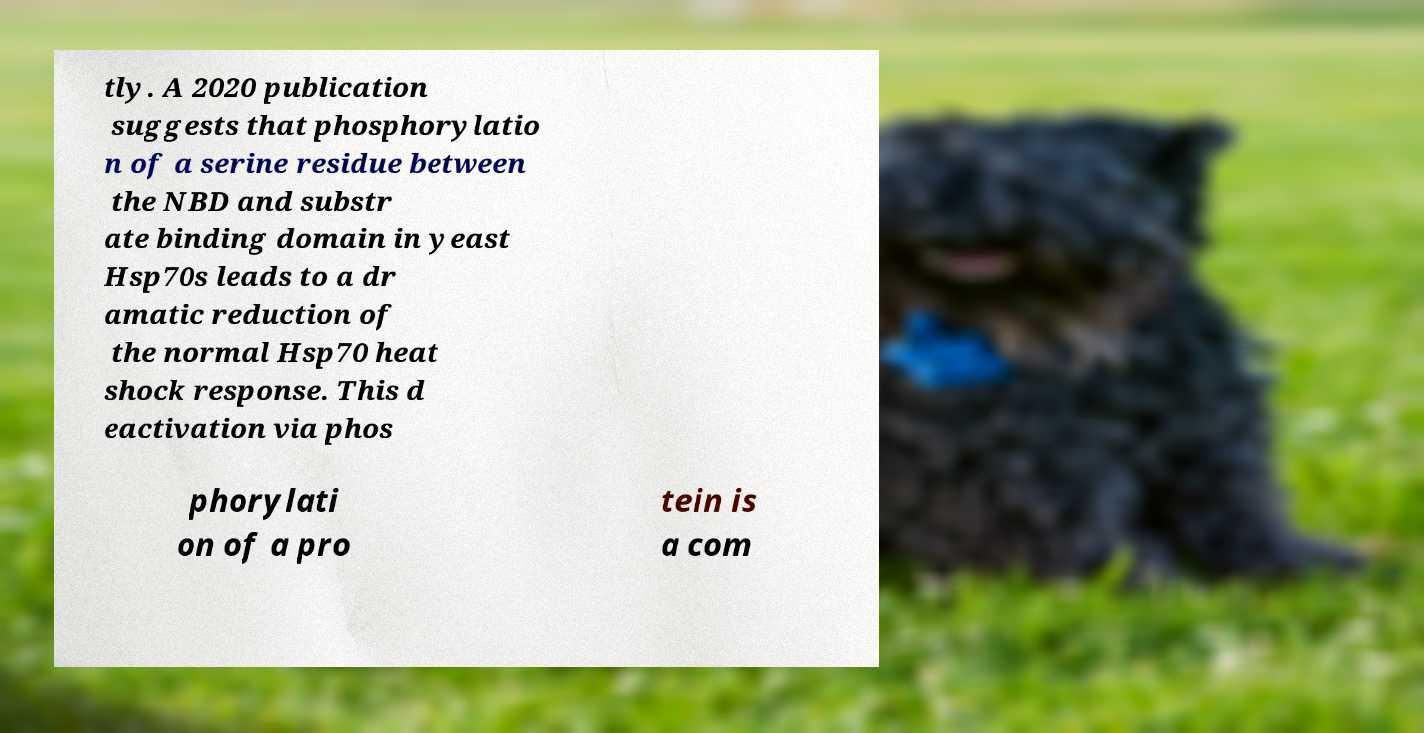For documentation purposes, I need the text within this image transcribed. Could you provide that? tly. A 2020 publication suggests that phosphorylatio n of a serine residue between the NBD and substr ate binding domain in yeast Hsp70s leads to a dr amatic reduction of the normal Hsp70 heat shock response. This d eactivation via phos phorylati on of a pro tein is a com 